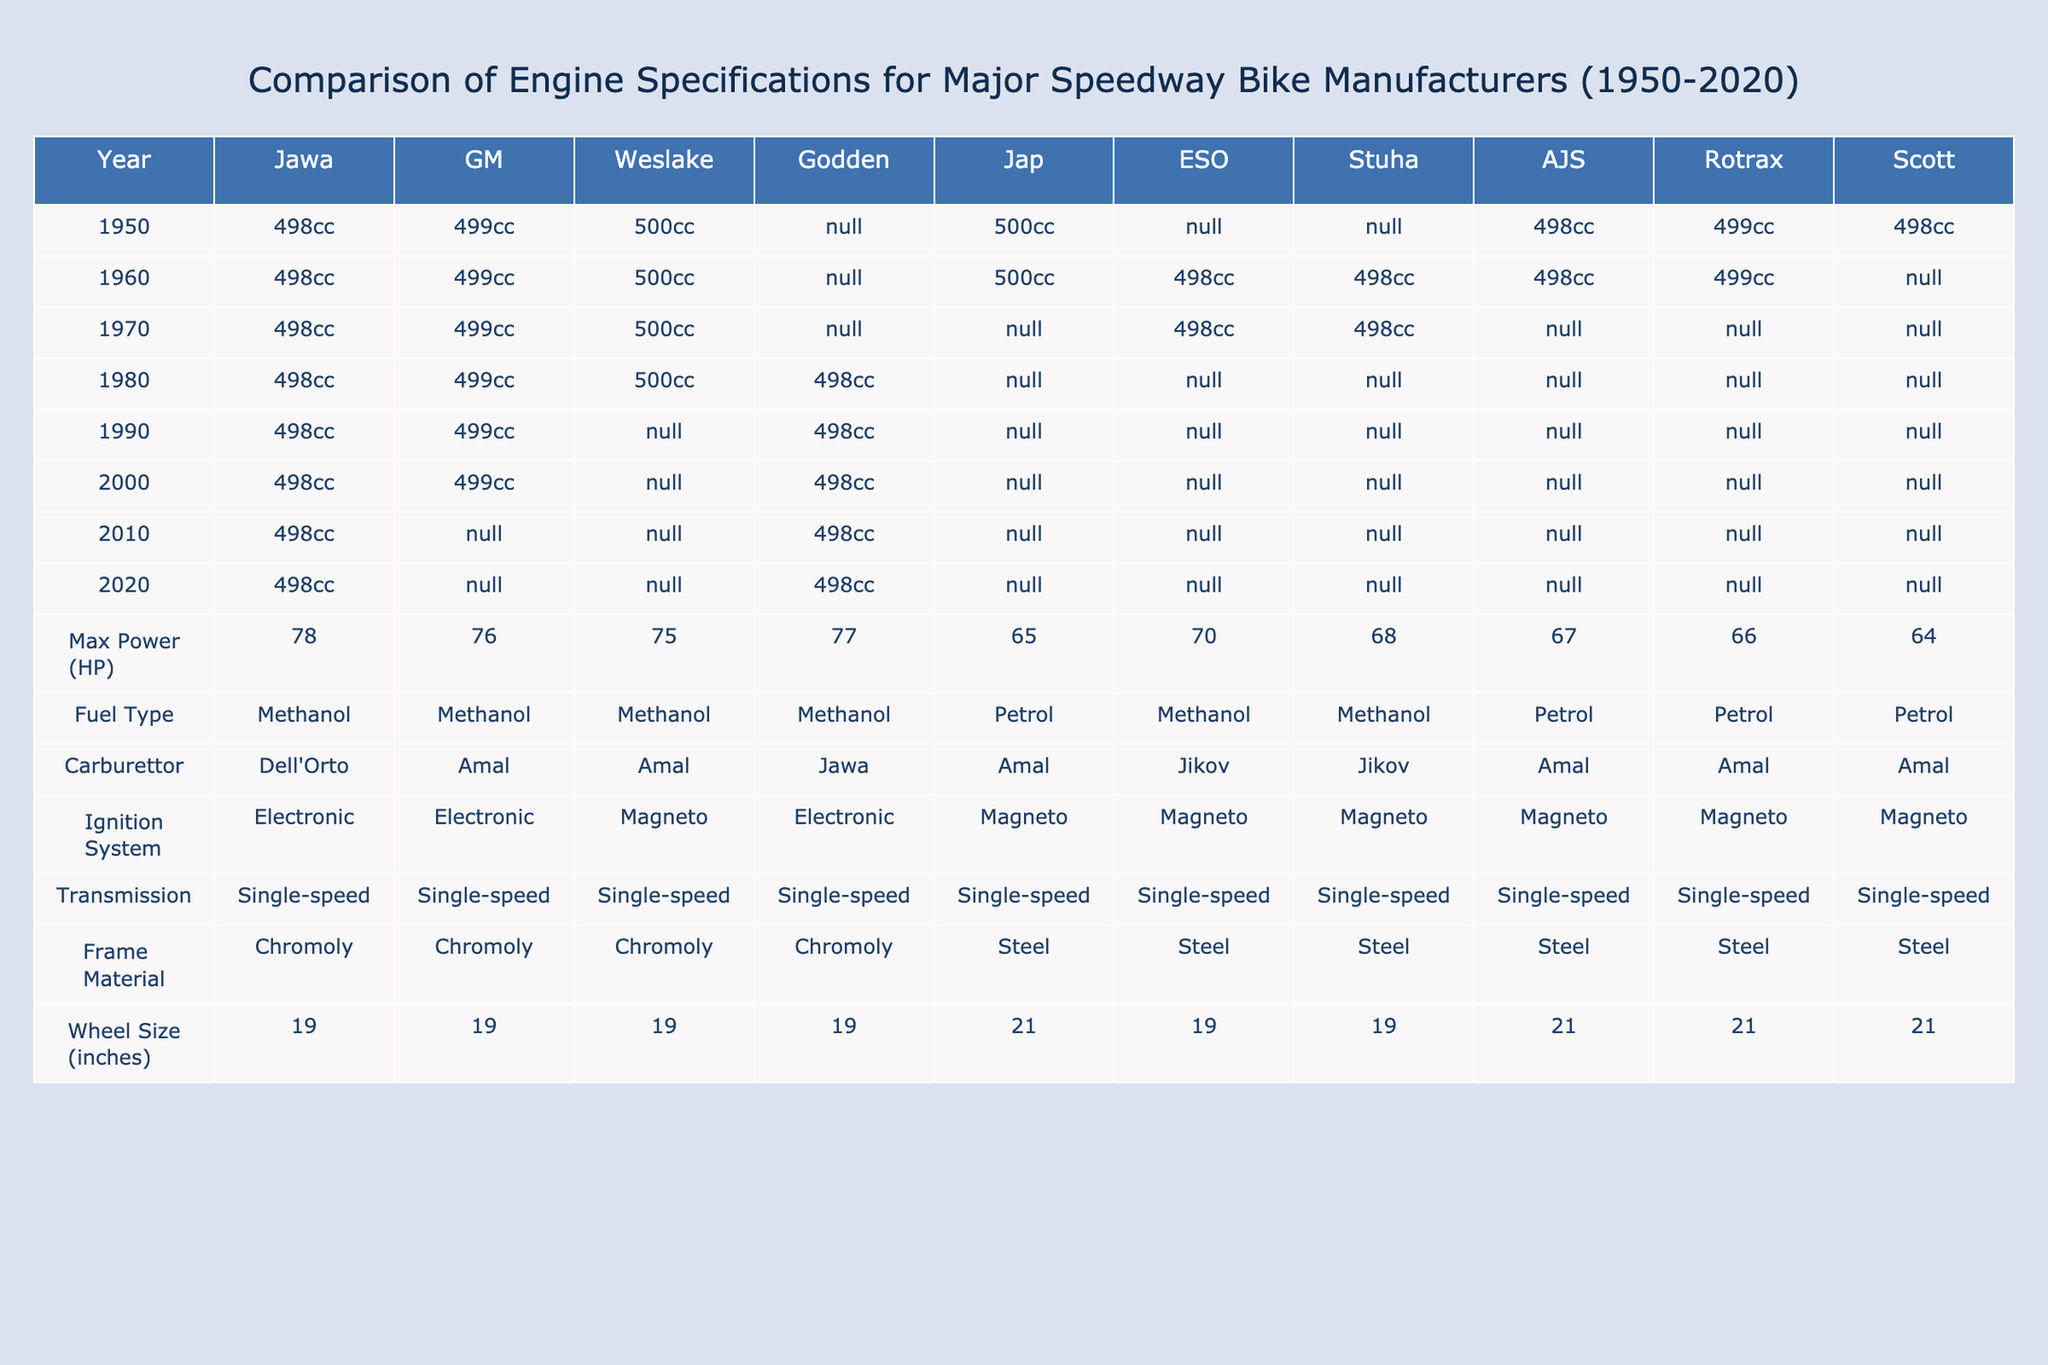What is the maximum power of a Jawa engine? The maximum power for Jawa engines is listed in the table as 78 HP.
Answer: 78 HP Which manufacturer had the lowest maximum power output? By examining the max power outputs for each manufacturer, the lowest is Jap at 65 HP.
Answer: Jap Did any manufacturer use petrol as a fuel type? Yes, according to the table, Jap and AJS use petrol as their fuel type.
Answer: Yes Which manufacturer had a 500cc engine in the 1960s? Looking at the table for the year 1960, Weslake, Jawa, and GM all had 500cc engines.
Answer: Weslake, Jawa, GM In which years did Rotrax have a defined engine specification? The Rotrax engine specs can be seen in the years 1950, 1960, and 1970.
Answer: 1950, 1960, 1970 What is the average maximum power of all manufacturers in the year 1990? The maximum power values for 1990 are 78, 76, 75, 77, 65, 70, 68, 67, 66, 64. Adding these gives 750 HP, and dividing by 10 manufacturers gives an average of 75 HP.
Answer: 75 HP Which manufacturer has the highest engine capacity in 1980? In 1980, all manufacturers, except Godden, had 500cc engines. Thus, the highest engine capacity is 500cc.
Answer: 500cc Is there a manufacturer that consistently had a 498cc engine throughout all decades? Yes, Jawa consistently had a 498cc engine from 1950 through 2020.
Answer: Yes Which manufacturers used a single-speed transmission system? All manufacturers listed used a single-speed transmission system as indicated in the table.
Answer: All manufacturers How many manufacturers used a carburettor manufactured by Amal? The manufacturers using Amal carburettors are GM, Weslake, and AJS. That’s a total of three manufacturers.
Answer: 3 What percentage of manufacturers used methanol as a fuel type? There are 10 manufacturers, and 7 of them use methanol, which gives (7/10)*100 = 70%.
Answer: 70% Which engine capacity was most common in the 1970s? The table shows that 498cc and 500cc were the prevalent engine capacities in the 1970s; however, 498cc is listed for all manufacturers except for those marked as N/A.
Answer: 498cc Are there any manufacturers that had a change in fuel type from methanol to petrol over the decades? Yes, Jap transitioned from petrol in later years while most others consistently used methanol.
Answer: Yes 